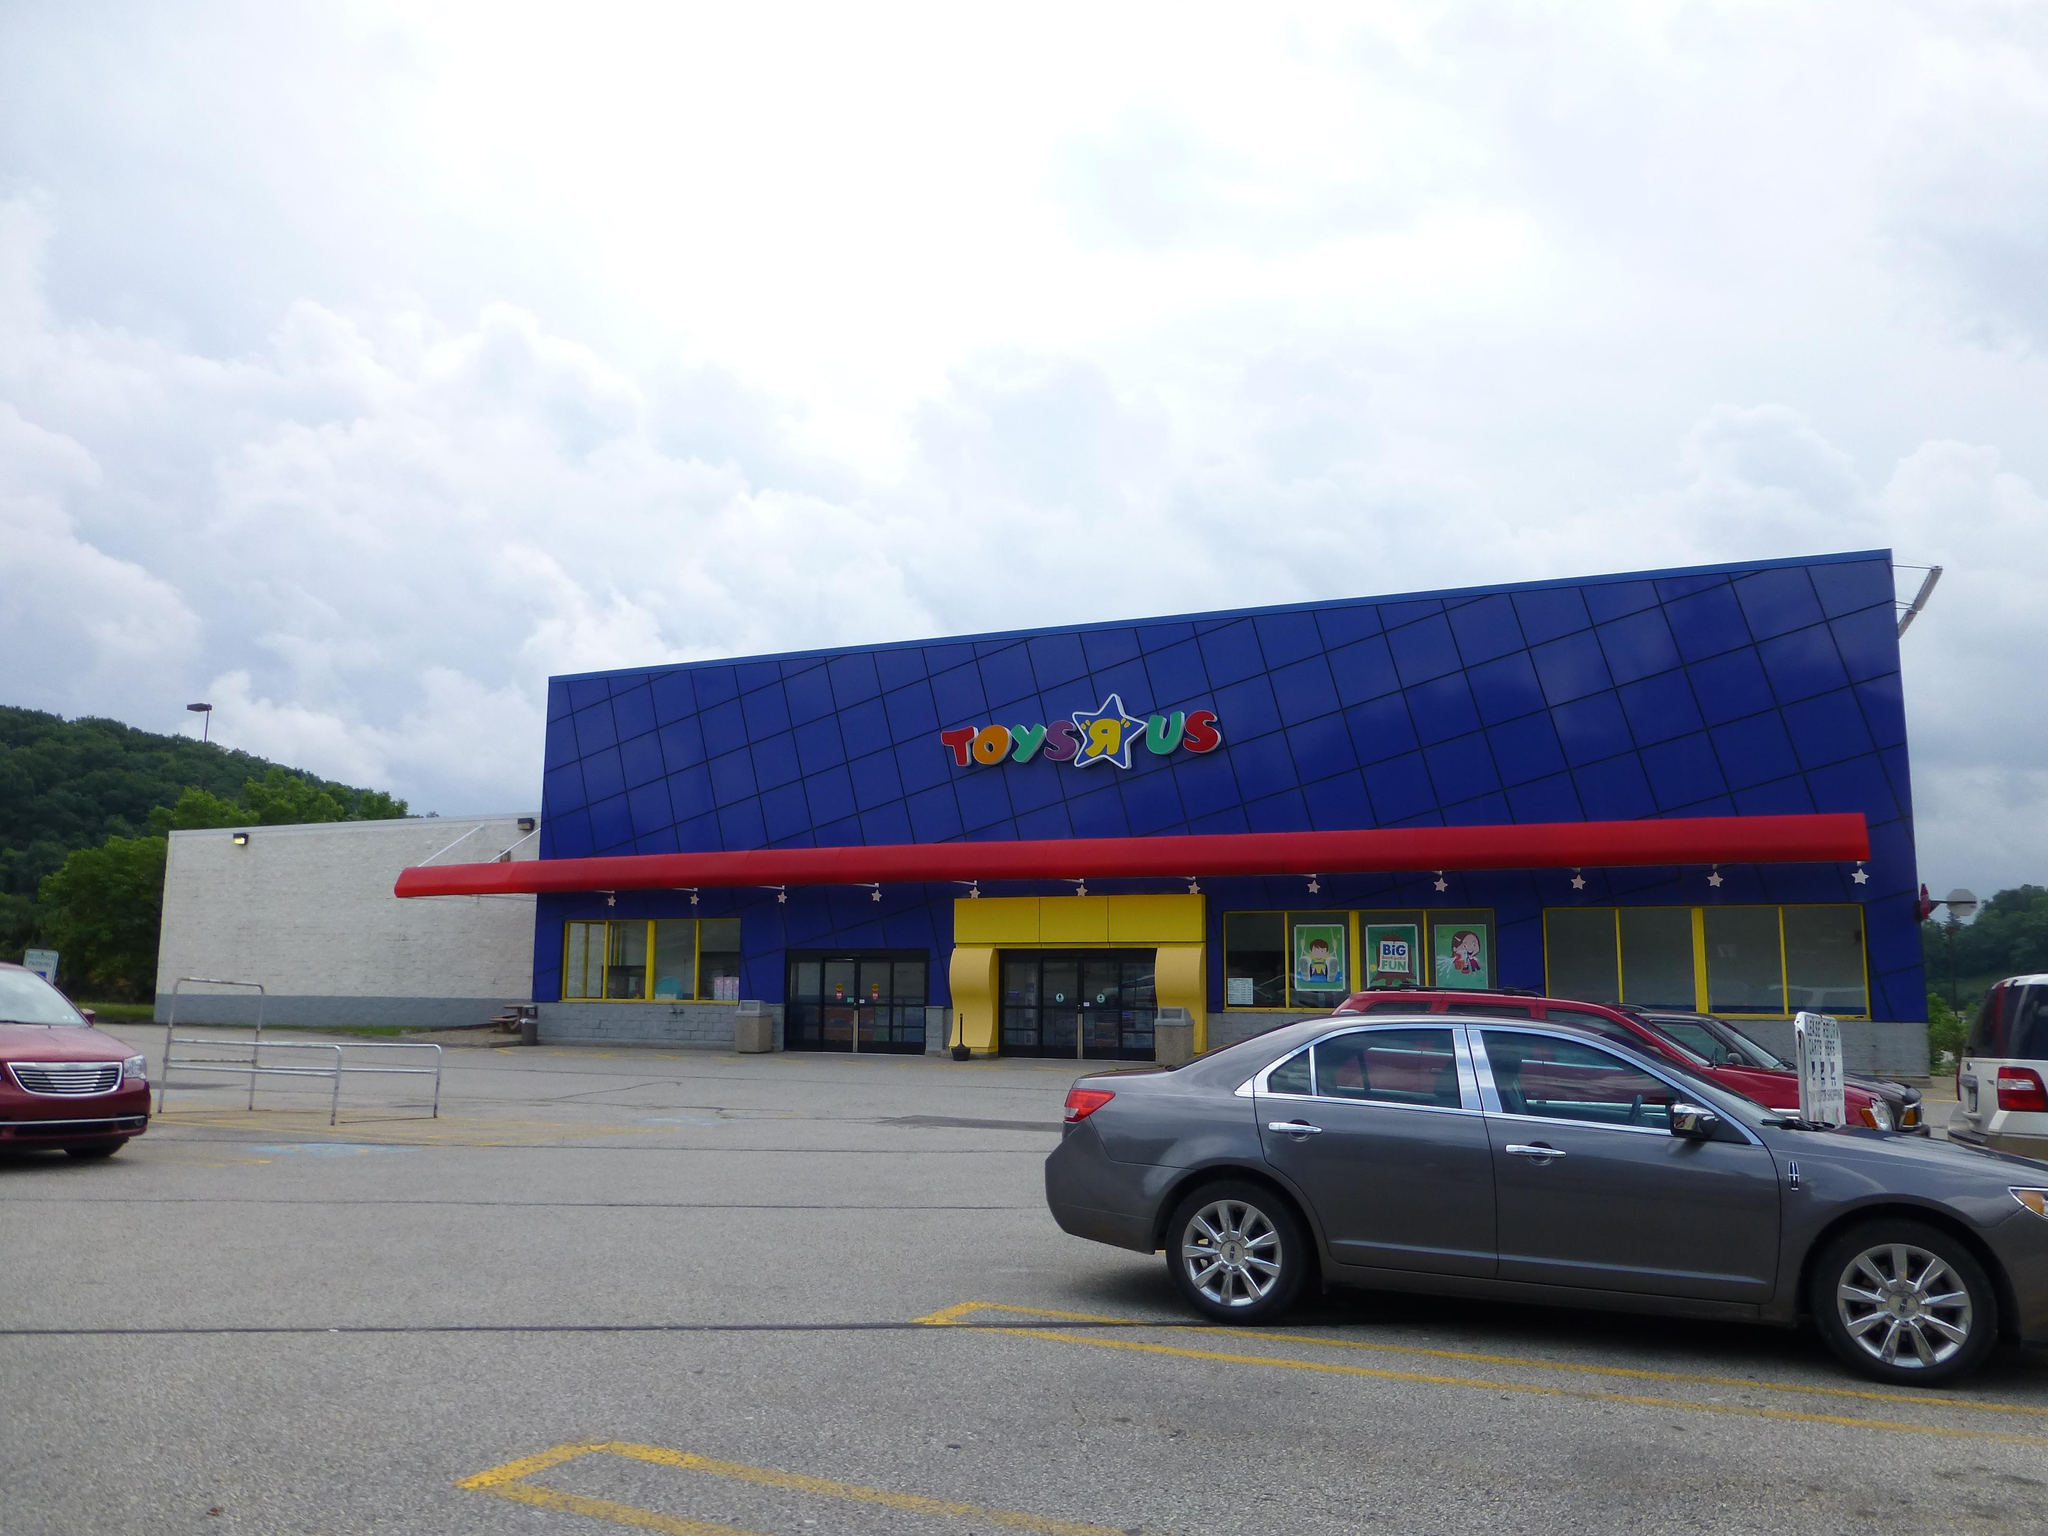What can be seen on the right side of the image? There are cars and trees on the right side of the image. What is located in the middle of the image? There is a building in the middle of the image. What is on the left side of the image? There is a car and a hill on the left side of the image, as well as trees. What is visible in the image besides the cars, trees, and building? The sky is visible in the image, and there are clouds in the sky. Where is the dock located in the image? There is no dock present in the image. What type of trade is being conducted in the image? There is no trade being conducted in the image. 